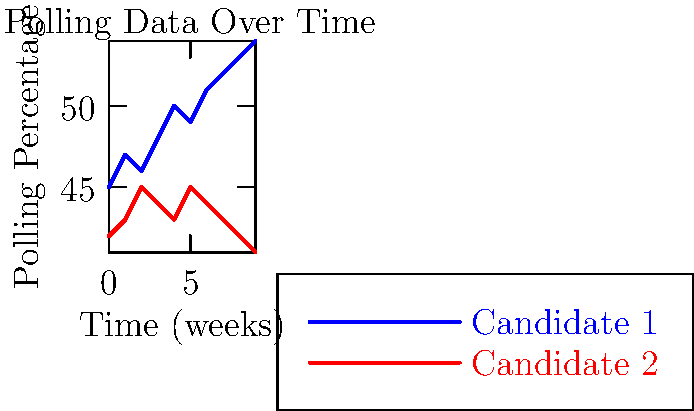Given the polling data shown in the graph, how might persistent homology be used to analyze the shape of this data over time, and what topological features could potentially be revealed? To analyze the shape of polling data over time using persistent homology, we would follow these steps:

1. Data representation: Convert the polling data into a point cloud in a higher-dimensional space, where each dimension represents a candidate's polling percentage at a given time.

2. Filtration: Create a sequence of simplicial complexes by gradually increasing the radius around each data point and connecting points within that radius.

3. Persistent homology computation: Calculate the homology groups at each step of the filtration, tracking how topological features (e.g., connected components, loops) appear and disappear.

4. Persistence diagram: Generate a persistence diagram that shows the birth and death times of topological features.

5. Interpretation: Analyze the persistence diagram to identify significant topological features:

   a. Connected components (0-dimensional features) could represent distinct clusters of polling patterns.
   b. Loops (1-dimensional features) might indicate periodic behavior or oscillations in polling data.
   c. Voids (2-dimensional features) could represent complex relationships between multiple candidates.

6. Comparison: Compare persistence diagrams from different time periods or elections to identify changes in the topological structure of polling data over time.

In this specific case, persistent homology analysis might reveal:

- A single dominant connected component, indicating overall consistency in the polling trends.
- Potential short-lived loops early in the filtration process, representing minor fluctuations in polling numbers.
- The absence of significant higher-dimensional features, suggesting a relatively simple topological structure in the data.

The persistent homology approach would provide a more robust analysis of the polling data's shape, capturing global structures and relationships that might not be apparent from traditional statistical methods.
Answer: Persistent homology can reveal connected components, loops, and voids in polling data, providing insights into data clusters, periodic behavior, and complex relationships between candidates. 